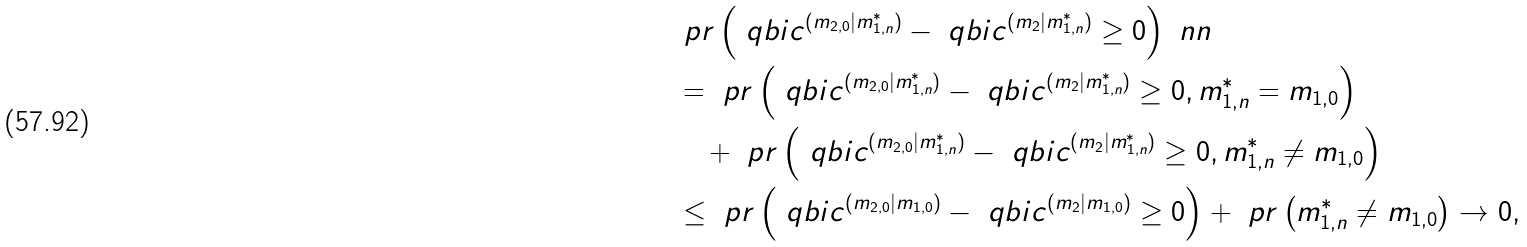Convert formula to latex. <formula><loc_0><loc_0><loc_500><loc_500>& \ p r \left ( \ q b i c ^ { ( m _ { 2 , 0 } | m _ { 1 , n } ^ { \ast } ) } - \ q b i c ^ { ( m _ { 2 } | m _ { 1 , n } ^ { \ast } ) } \geq 0 \right ) \ n n \\ & = \ p r \left ( \ q b i c ^ { ( m _ { 2 , 0 } | m _ { 1 , n } ^ { \ast } ) } - \ q b i c ^ { ( m _ { 2 } | m _ { 1 , n } ^ { \ast } ) } \geq 0 , m _ { 1 , n } ^ { \ast } = m _ { 1 , 0 } \right ) \\ & \quad + \ p r \left ( \ q b i c ^ { ( m _ { 2 , 0 } | m _ { 1 , n } ^ { \ast } ) } - \ q b i c ^ { ( m _ { 2 } | m _ { 1 , n } ^ { \ast } ) } \geq 0 , m _ { 1 , n } ^ { \ast } \neq m _ { 1 , 0 } \right ) \\ & \leq \ p r \left ( \ q b i c ^ { ( m _ { 2 , 0 } | m _ { 1 , 0 } ) } - \ q b i c ^ { ( m _ { 2 } | m _ { 1 , 0 } ) } \geq 0 \right ) + \ p r \left ( m _ { 1 , n } ^ { \ast } \neq m _ { 1 , 0 } \right ) \to 0 ,</formula> 